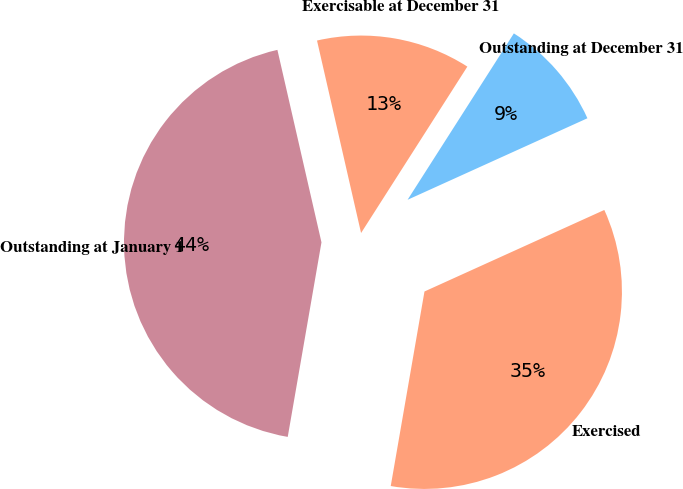Convert chart to OTSL. <chart><loc_0><loc_0><loc_500><loc_500><pie_chart><fcel>Outstanding at January 1<fcel>Exercised<fcel>Outstanding at December 31<fcel>Exercisable at December 31<nl><fcel>43.69%<fcel>34.51%<fcel>9.18%<fcel>12.63%<nl></chart> 